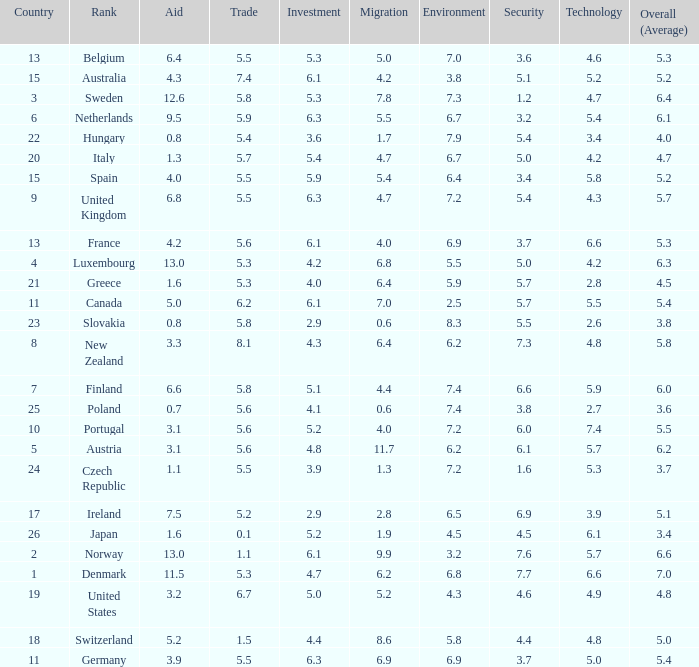What is the migration rating when trade is 5.7? 4.7. 